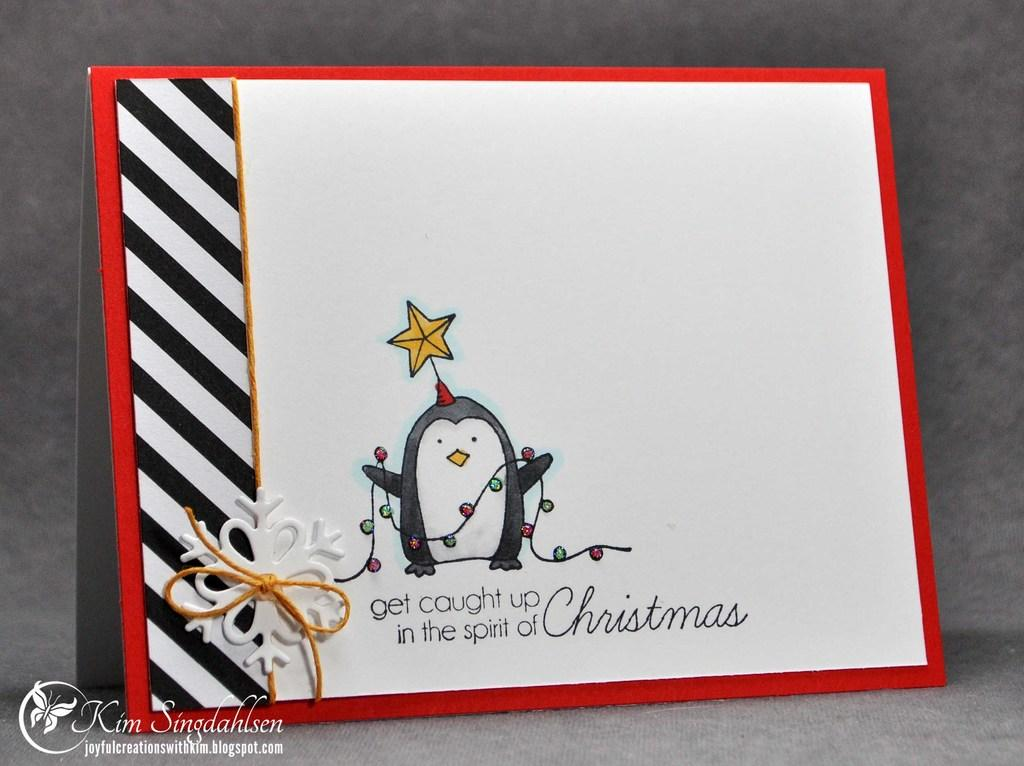What is the main object in the image? There is a card in the image. What can be found on the card? The card has text and a picture on it. Where is the text located in the image? There is text in the bottom left corner of the image. What can be seen in the background of the image? There is a wall in the background of the image. How does the pest learn to avoid the card in the image? There is no pest present in the image, so it cannot learn to avoid the card. 